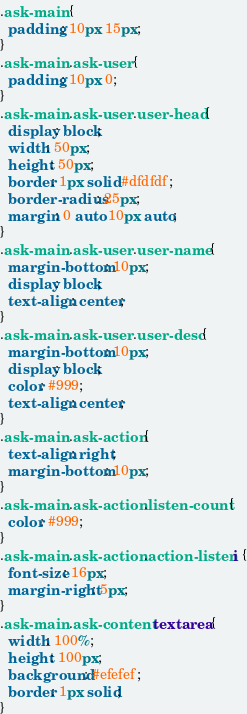<code> <loc_0><loc_0><loc_500><loc_500><_CSS_>.ask-main {
  padding: 10px 15px;
}
.ask-main .ask-user {
  padding: 10px 0;
}
.ask-main .ask-user .user-head {
  display: block;
  width: 50px;
  height: 50px;
  border: 1px solid #dfdfdf;
  border-radius: 25px;
  margin: 0 auto 10px auto;
}
.ask-main .ask-user .user-name {
  margin-bottom: 10px;
  display: block;
  text-align: center;
}
.ask-main .ask-user .user-desc {
  margin-bottom: 10px;
  display: block;
  color: #999;
  text-align: center;
}
.ask-main .ask-action {
  text-align: right;
  margin-bottom: 10px;
}
.ask-main .ask-action .listen-count {
  color: #999;
}
.ask-main .ask-action .action-listen i {
  font-size: 16px;
  margin-right: 5px;
}
.ask-main .ask-content textarea {
  width: 100%;
  height: 100px;
  background: #efefef;
  border: 1px solid;
}
</code> 